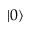<formula> <loc_0><loc_0><loc_500><loc_500>| 0 \rangle</formula> 